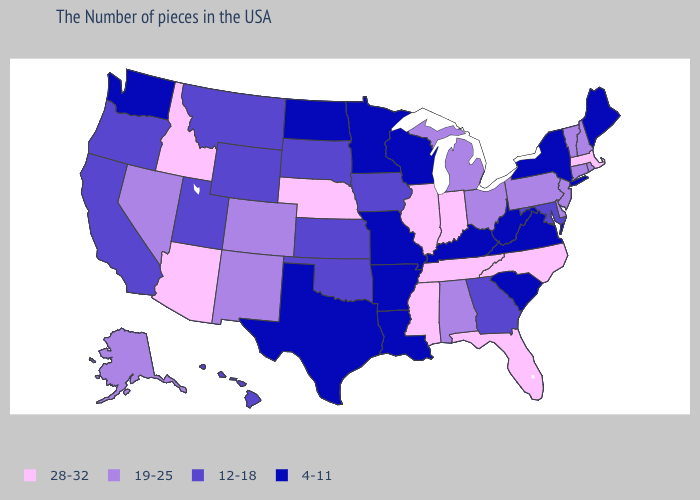What is the value of Ohio?
Keep it brief. 19-25. Does Florida have the highest value in the South?
Quick response, please. Yes. Name the states that have a value in the range 4-11?
Short answer required. Maine, New York, Virginia, South Carolina, West Virginia, Kentucky, Wisconsin, Louisiana, Missouri, Arkansas, Minnesota, Texas, North Dakota, Washington. What is the value of Kansas?
Give a very brief answer. 12-18. Name the states that have a value in the range 4-11?
Answer briefly. Maine, New York, Virginia, South Carolina, West Virginia, Kentucky, Wisconsin, Louisiana, Missouri, Arkansas, Minnesota, Texas, North Dakota, Washington. Which states have the lowest value in the USA?
Short answer required. Maine, New York, Virginia, South Carolina, West Virginia, Kentucky, Wisconsin, Louisiana, Missouri, Arkansas, Minnesota, Texas, North Dakota, Washington. Name the states that have a value in the range 4-11?
Answer briefly. Maine, New York, Virginia, South Carolina, West Virginia, Kentucky, Wisconsin, Louisiana, Missouri, Arkansas, Minnesota, Texas, North Dakota, Washington. Among the states that border Kentucky , which have the highest value?
Give a very brief answer. Indiana, Tennessee, Illinois. Does Oregon have the lowest value in the West?
Short answer required. No. What is the value of Rhode Island?
Quick response, please. 19-25. What is the lowest value in the West?
Write a very short answer. 4-11. What is the lowest value in the USA?
Be succinct. 4-11. Name the states that have a value in the range 19-25?
Give a very brief answer. Rhode Island, New Hampshire, Vermont, Connecticut, New Jersey, Delaware, Pennsylvania, Ohio, Michigan, Alabama, Colorado, New Mexico, Nevada, Alaska. Does Florida have the highest value in the South?
Answer briefly. Yes. What is the value of Wisconsin?
Give a very brief answer. 4-11. 